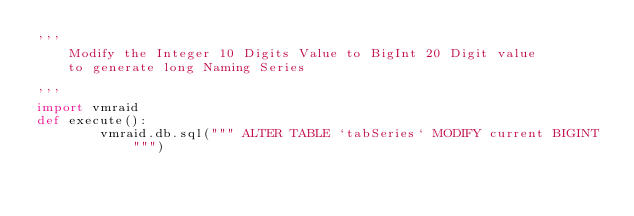Convert code to text. <code><loc_0><loc_0><loc_500><loc_500><_Python_>'''
    Modify the Integer 10 Digits Value to BigInt 20 Digit value
    to generate long Naming Series

'''
import vmraid
def execute():
        vmraid.db.sql(""" ALTER TABLE `tabSeries` MODIFY current BIGINT """)
</code> 